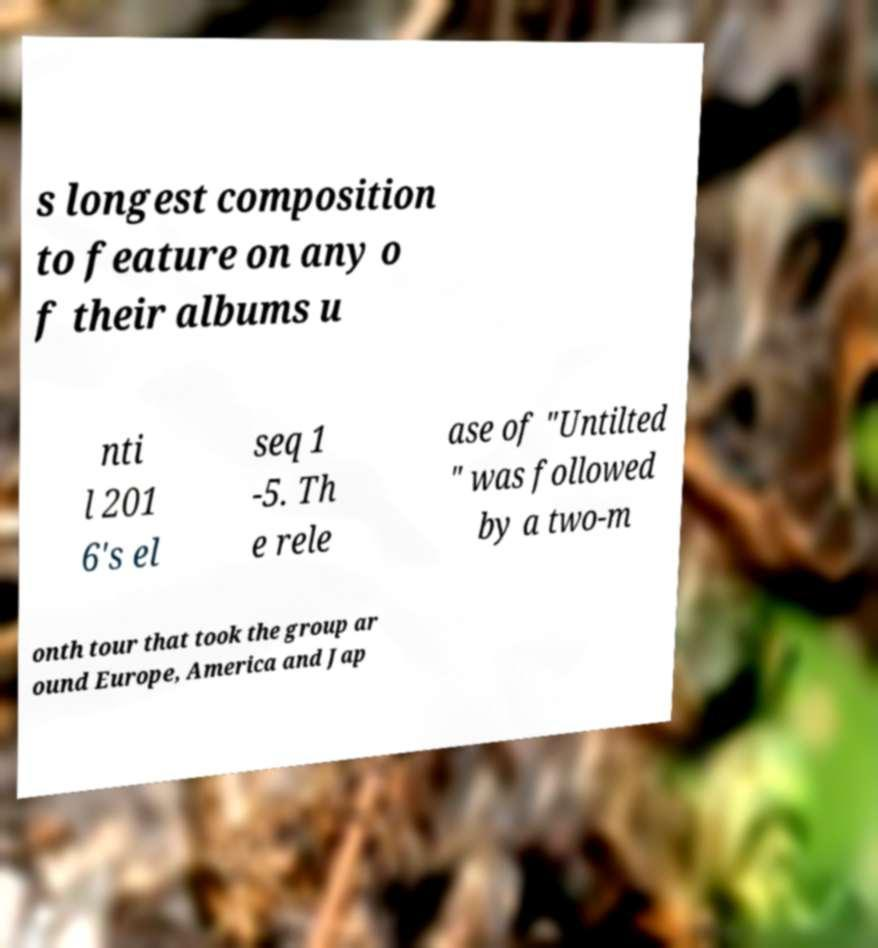Can you read and provide the text displayed in the image?This photo seems to have some interesting text. Can you extract and type it out for me? s longest composition to feature on any o f their albums u nti l 201 6's el seq 1 -5. Th e rele ase of "Untilted " was followed by a two-m onth tour that took the group ar ound Europe, America and Jap 